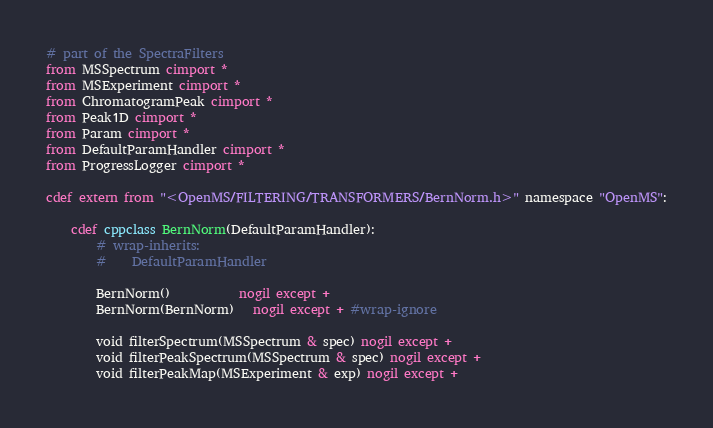<code> <loc_0><loc_0><loc_500><loc_500><_Cython_># part of the SpectraFilters
from MSSpectrum cimport *
from MSExperiment cimport *
from ChromatogramPeak cimport *
from Peak1D cimport *
from Param cimport *
from DefaultParamHandler cimport *
from ProgressLogger cimport *

cdef extern from "<OpenMS/FILTERING/TRANSFORMERS/BernNorm.h>" namespace "OpenMS":

    cdef cppclass BernNorm(DefaultParamHandler):
        # wrap-inherits:
        #    DefaultParamHandler

        BernNorm()           nogil except +
        BernNorm(BernNorm)   nogil except + #wrap-ignore

        void filterSpectrum(MSSpectrum & spec) nogil except +
        void filterPeakSpectrum(MSSpectrum & spec) nogil except +
        void filterPeakMap(MSExperiment & exp) nogil except +

</code> 